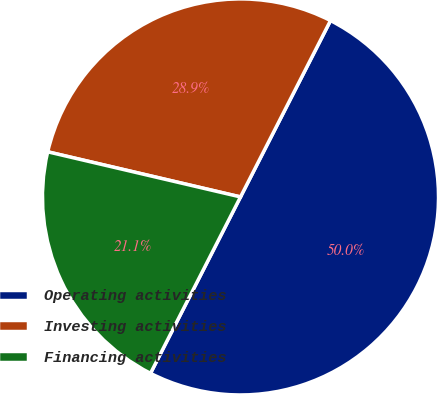Convert chart to OTSL. <chart><loc_0><loc_0><loc_500><loc_500><pie_chart><fcel>Operating activities<fcel>Investing activities<fcel>Financing activities<nl><fcel>50.0%<fcel>28.85%<fcel>21.15%<nl></chart> 